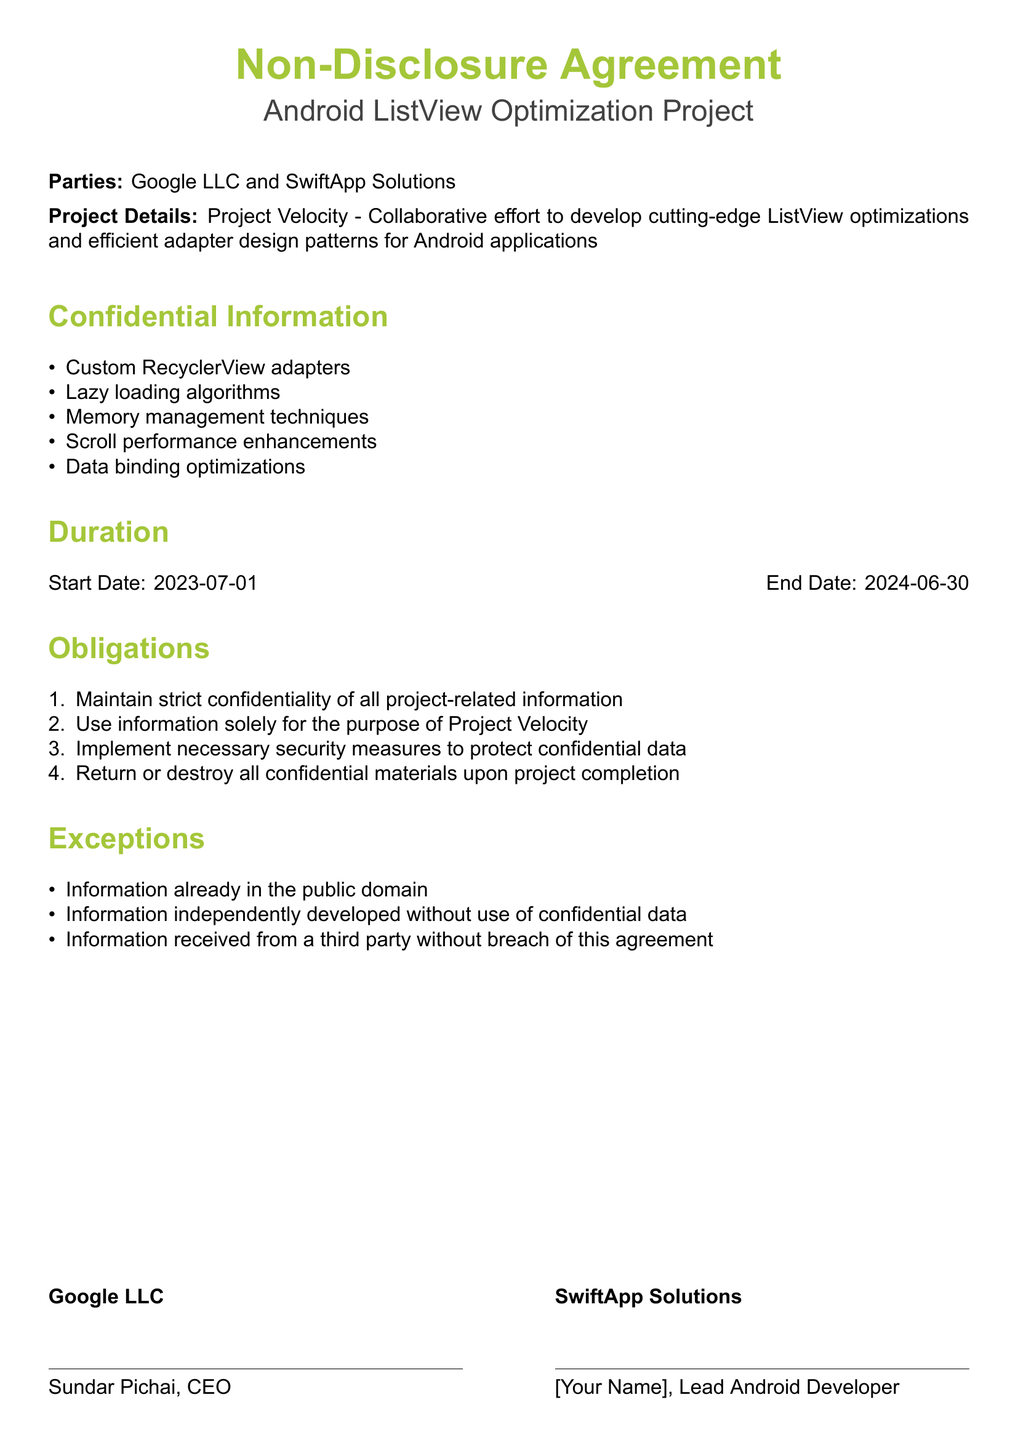What is the name of the project? The project is referred to as "Project Velocity" in the document.
Answer: Project Velocity Who are the parties involved? The parties involved, as stated, are Google LLC and SwiftApp Solutions.
Answer: Google LLC and SwiftApp Solutions What is the start date of the agreement? The agreement specifies the start date as July 1, 2023.
Answer: 2023-07-01 How many obligations are listed? There are four obligations outlined in the document.
Answer: 4 What information is excluded from confidentiality? The document specifies that information already in the public domain is excluded from confidentiality.
Answer: Information already in the public domain What is the end date of the project? The project end date is indicated as June 30, 2024.
Answer: 2024-06-30 Who is the CEO of Google LLC? The document states that Sundar Pichai is the CEO of Google LLC.
Answer: Sundar Pichai What is one technique mentioned for Scroll performance enhancements? The document lists "Scroll performance enhancements," but does not specify a technique.
Answer: Scroll performance enhancements What type of algorithms are being developed in this project? The project involves "Lazy loading algorithms."
Answer: Lazy loading algorithms 